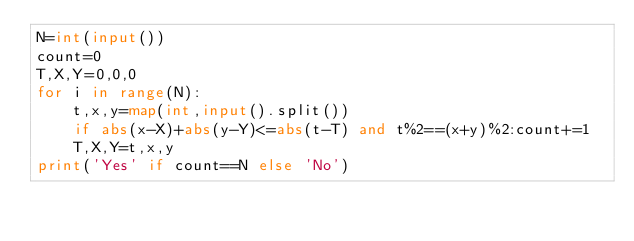<code> <loc_0><loc_0><loc_500><loc_500><_Python_>N=int(input())
count=0
T,X,Y=0,0,0
for i in range(N):
    t,x,y=map(int,input().split())
    if abs(x-X)+abs(y-Y)<=abs(t-T) and t%2==(x+y)%2:count+=1
    T,X,Y=t,x,y
print('Yes' if count==N else 'No')</code> 